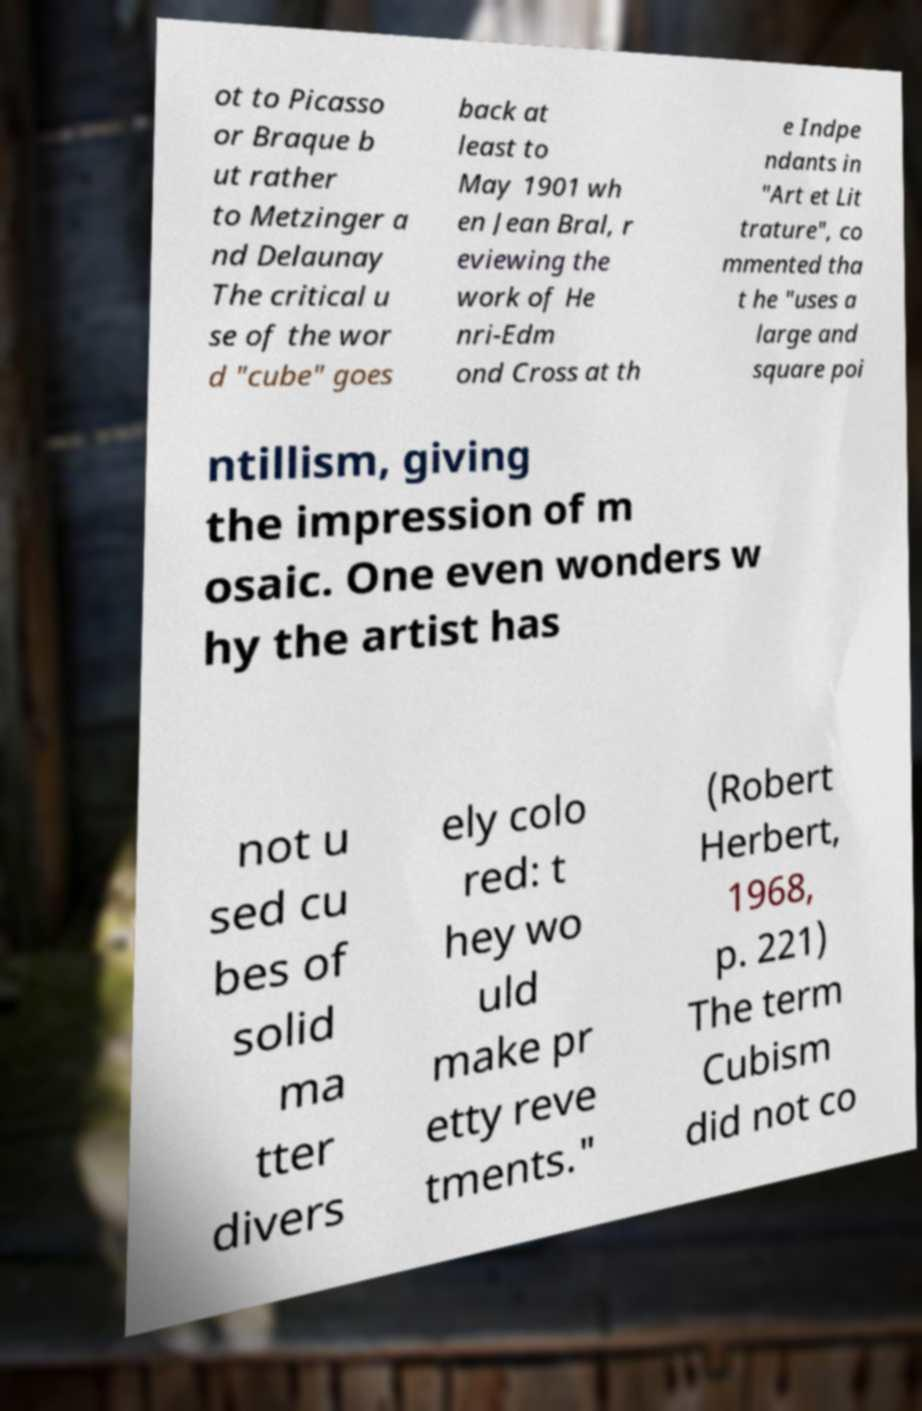Please identify and transcribe the text found in this image. ot to Picasso or Braque b ut rather to Metzinger a nd Delaunay The critical u se of the wor d "cube" goes back at least to May 1901 wh en Jean Bral, r eviewing the work of He nri-Edm ond Cross at th e Indpe ndants in "Art et Lit trature", co mmented tha t he "uses a large and square poi ntillism, giving the impression of m osaic. One even wonders w hy the artist has not u sed cu bes of solid ma tter divers ely colo red: t hey wo uld make pr etty reve tments." (Robert Herbert, 1968, p. 221) The term Cubism did not co 